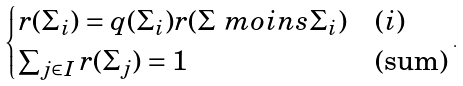Convert formula to latex. <formula><loc_0><loc_0><loc_500><loc_500>\begin{cases} r ( \Sigma _ { i } ) = q ( \Sigma _ { i } ) r ( \Sigma \ m o i n s \Sigma _ { i } ) & ( i ) \\ \sum _ { j \in I } r ( \Sigma _ { j } ) = 1 & ( \text {sum} ) \end{cases} \, .</formula> 